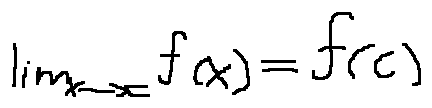<formula> <loc_0><loc_0><loc_500><loc_500>\lim \lim i t s _ { x \rightarrow c } f ( x ) = f ( c )</formula> 